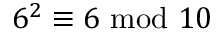<formula> <loc_0><loc_0><loc_500><loc_500>6 ^ { 2 } \equiv 6 { m o d } 1 0</formula> 